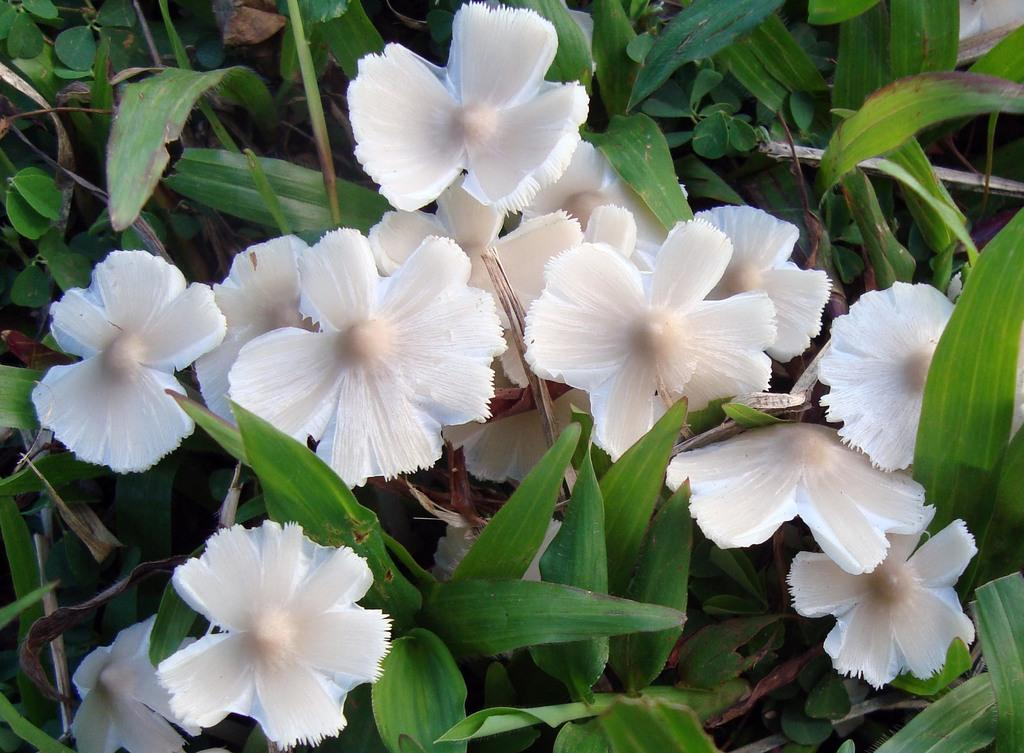What type of flora is present in the image? There are flowers and plants in the image. What color are the flowers in the image? The flowers in the image are white. What color are the leaves in the image? The leaves in the image are green. What type of jelly can be seen on the leaves in the image? There is no jelly present on the leaves in the image; the leaves are green. 